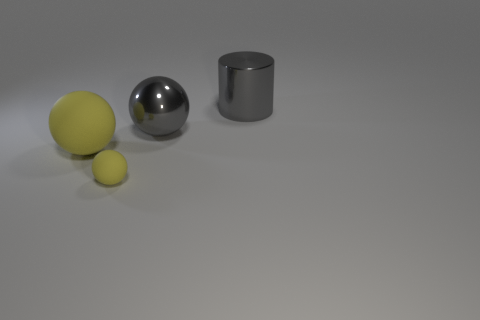How many yellow spheres must be subtracted to get 1 yellow spheres? 1 Subtract all rubber spheres. How many spheres are left? 1 Add 2 tiny purple objects. How many objects exist? 6 Subtract all blue cubes. How many yellow balls are left? 2 Subtract all cylinders. How many objects are left? 3 Subtract 1 balls. How many balls are left? 2 Add 4 rubber things. How many rubber things are left? 6 Add 4 small yellow matte balls. How many small yellow matte balls exist? 5 Subtract 0 brown cylinders. How many objects are left? 4 Subtract all red cylinders. Subtract all cyan cubes. How many cylinders are left? 1 